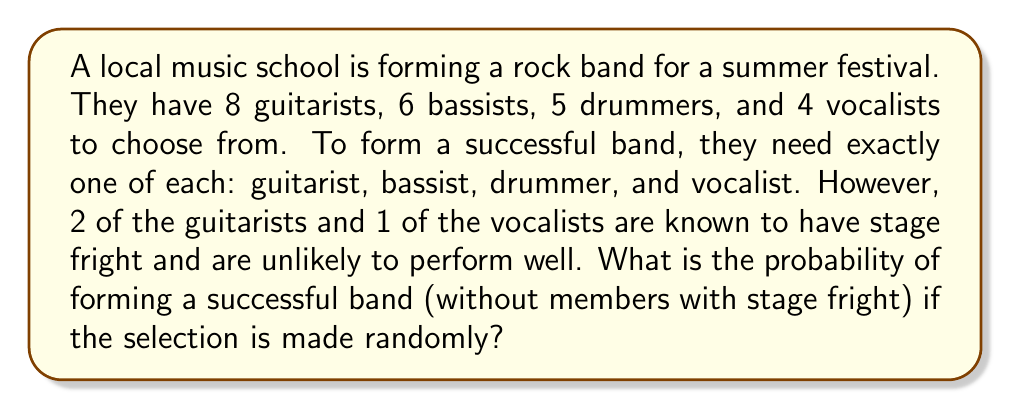Could you help me with this problem? Let's approach this step-by-step:

1) First, we need to calculate the total number of possible band combinations:
   $$ \text{Total combinations} = 8 \times 6 \times 5 \times 4 = 960 $$

2) Now, we need to calculate the number of successful band combinations (without members with stage fright):
   - Guitarists without stage fright: 6
   - Bassists: 6 (all can perform)
   - Drummers: 5 (all can perform)
   - Vocalists without stage fright: 3

   $$ \text{Successful combinations} = 6 \times 6 \times 5 \times 3 = 540 $$

3) The probability is the number of favorable outcomes divided by the total number of possible outcomes:

   $$ P(\text{successful band}) = \frac{\text{Successful combinations}}{\text{Total combinations}} = \frac{540}{960} = \frac{9}{16} = 0.5625 $$

Therefore, the probability of forming a successful band without members with stage fright is $\frac{9}{16}$ or 0.5625 or 56.25%.
Answer: $\frac{9}{16}$ or 0.5625 or 56.25% 